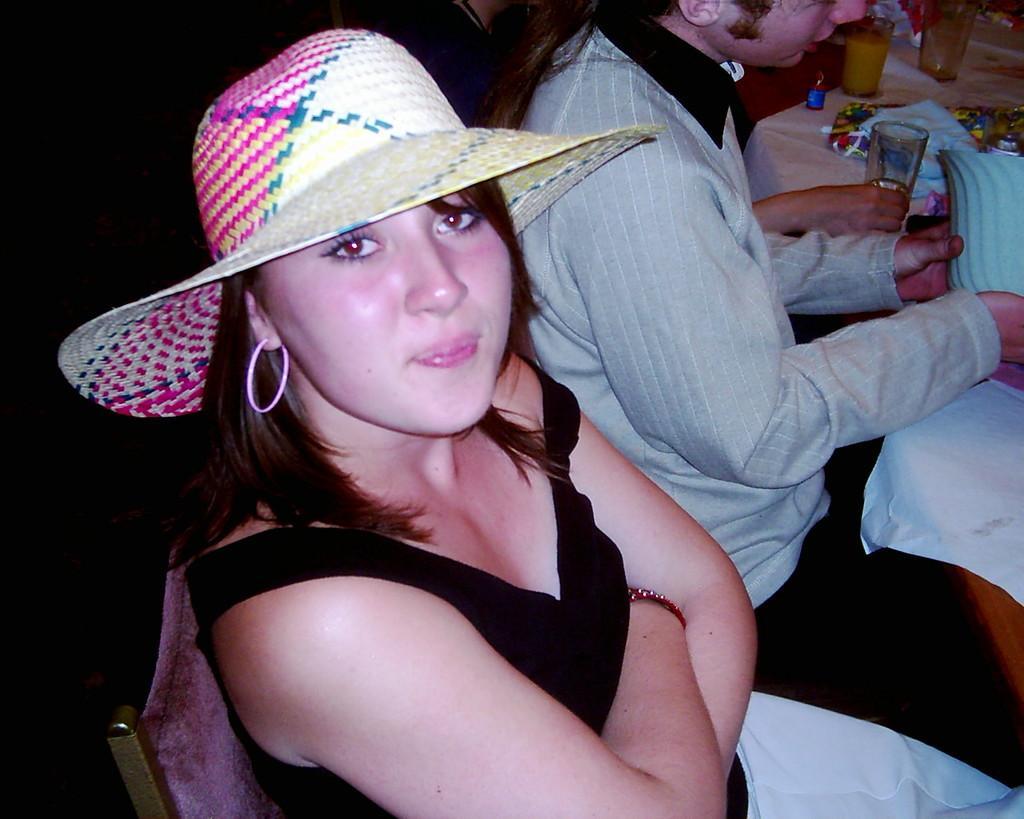How would you summarize this image in a sentence or two? Here I can see a woman and a man are sitting on the chairs facing towards the right side. The woman is smiling by looking at the picture. The man is holding an object in the hands and looking at the object. In front of these people there is a table which is covered with a white cloth. On the table few glasses, a cloth and some other objects are placed. The background is dark. 